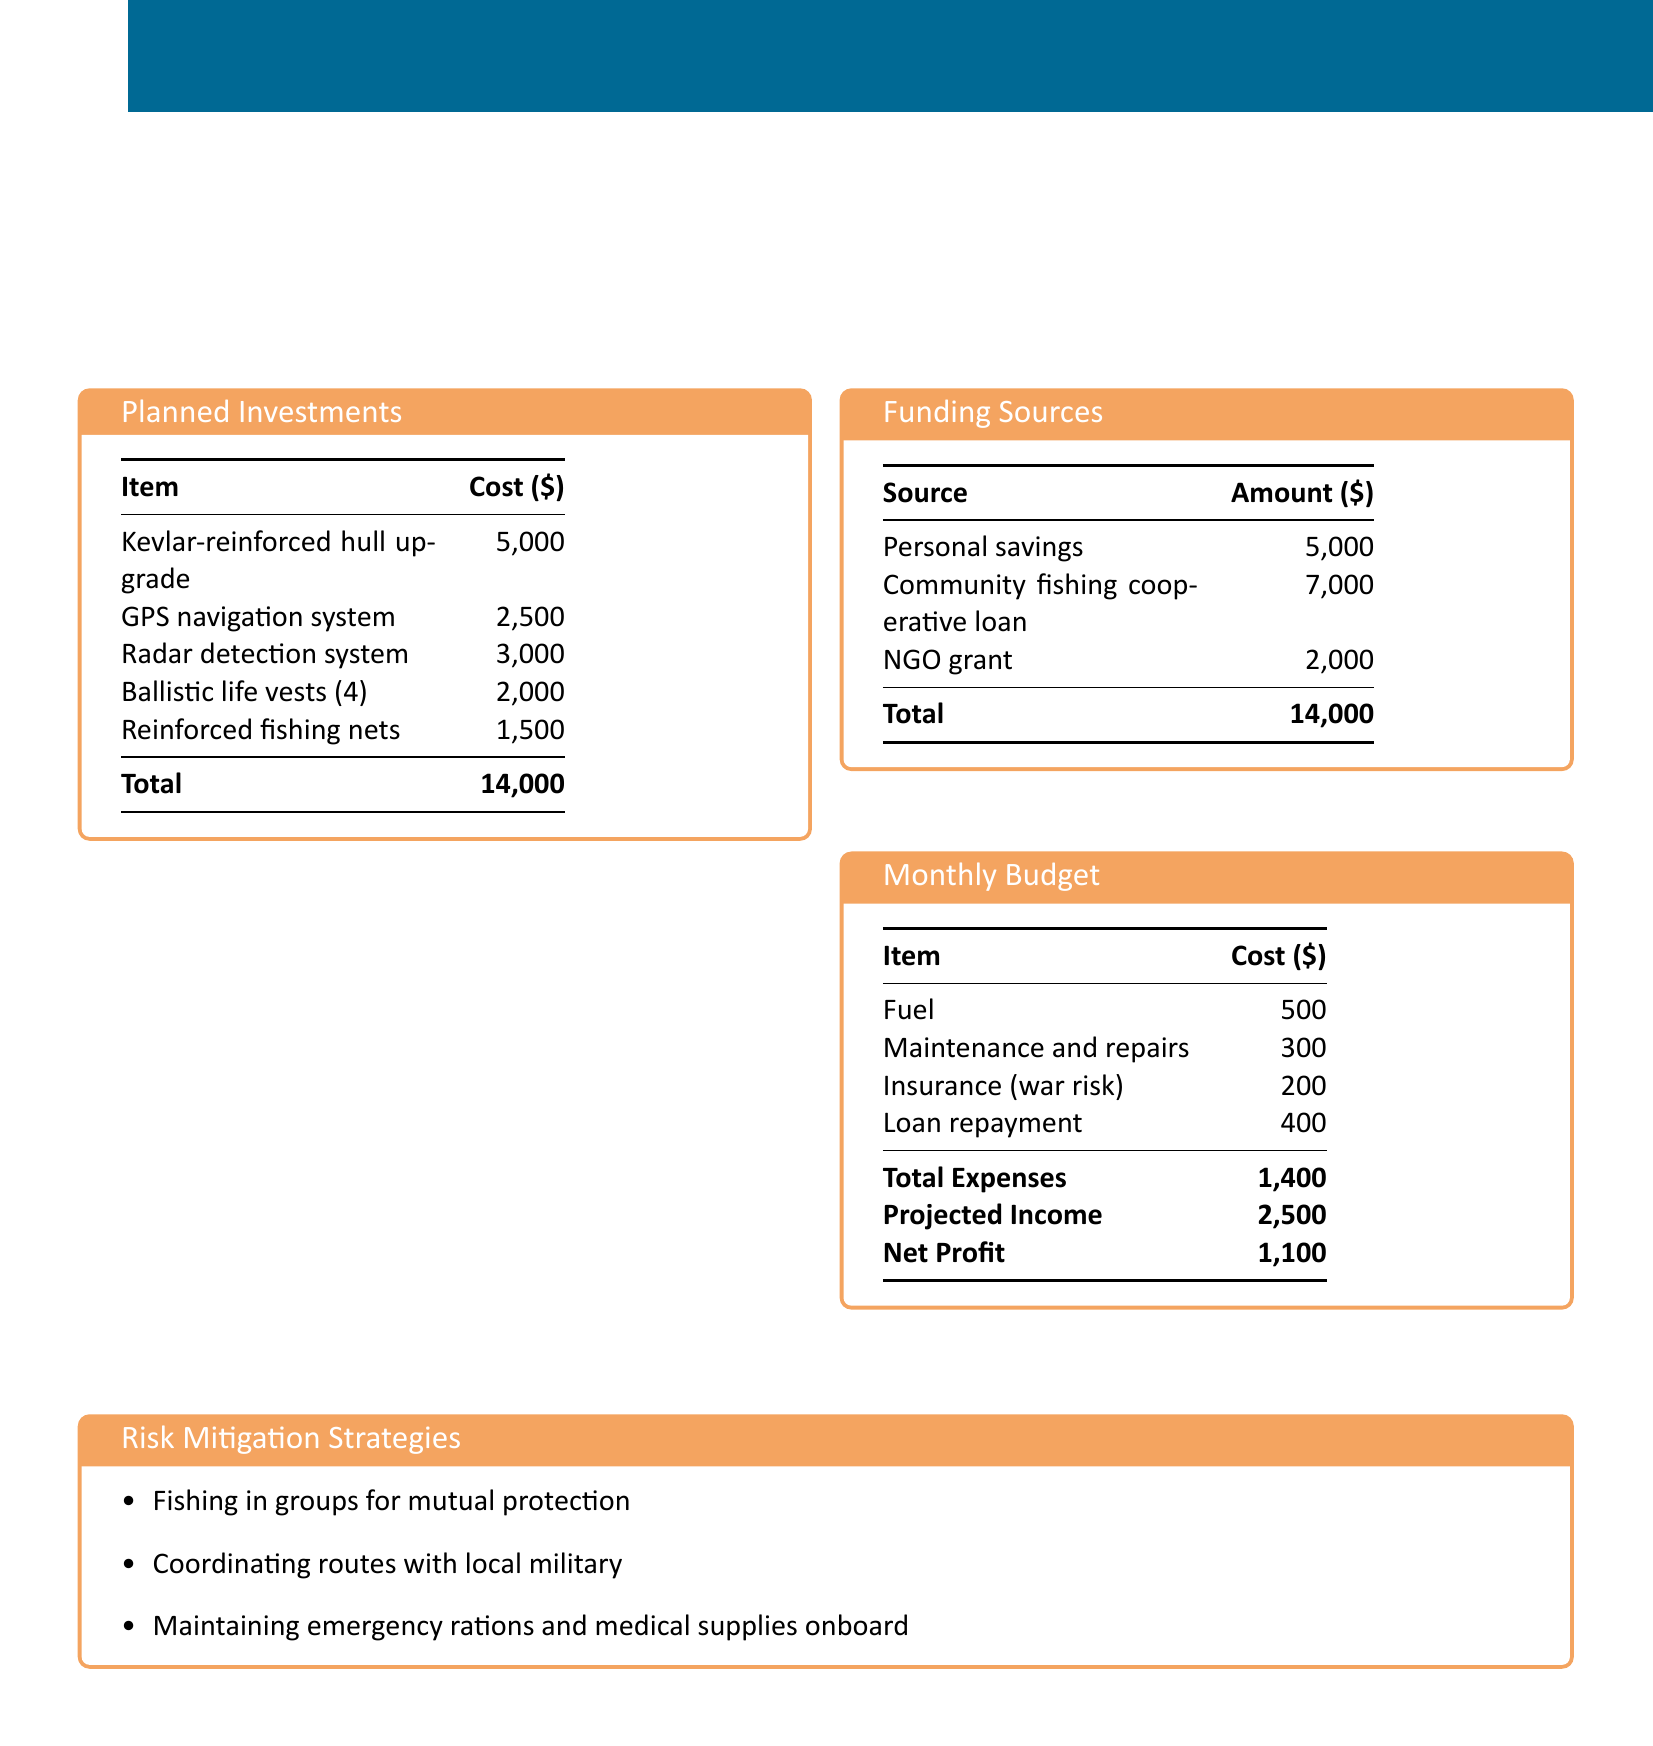What is the total cost for planned investments? The total cost for planned investments is listed as $14,000 in the document.
Answer: $14,000 How much is allocated for the GPS navigation system? The cost for the GPS navigation system is specified as $2,500.
Answer: $2,500 What is the source of the loan amount in the funding sources? The loan amount in the funding sources comes from the community fishing cooperative loan listed as $7,000.
Answer: $7,000 What is the net profit projected in the monthly budget? The net profit is calculated by subtracting total expenses from projected income, which totals $1,100.
Answer: $1,100 What type of fishing does the risk mitigation strategy emphasize? The strategy emphasizes fishing in groups for mutual protection.
Answer: Groups How much does the community fishing cooperative loan provide? The amount provided by the community fishing cooperative loan is $7,000 according to the funding sources.
Answer: $7,000 What is the cost of ballistic life vests? The cost for ballistic life vests is stated as $2,000 for four vests in the planned investments.
Answer: $2,000 What is included in the monthly budget for insurance? The monthly budget lists insurance (war risk) as costing $200.
Answer: $200 What emergency supplies are mentioned in the risk mitigation strategies? The emergency supplies mentioned include maintaining medical supplies onboard.
Answer: Medical supplies 